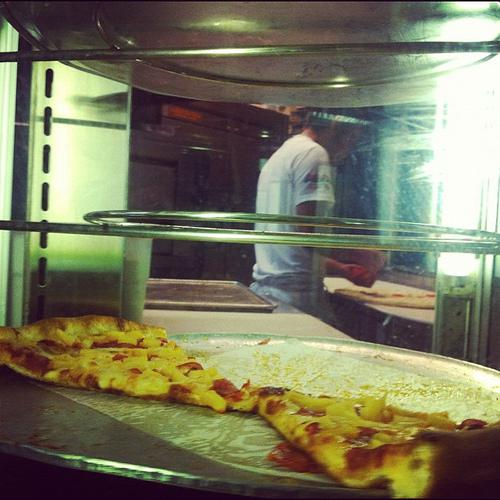Question: who is in the picture?
Choices:
A. The chef.
B. The cook.
C. The baker.
D. The pizza maker.
Answer with the letter. Answer: D Question: what color is the man's shirt?
Choices:
A. Grey.
B. Blue.
C. Tan.
D. White.
Answer with the letter. Answer: D 